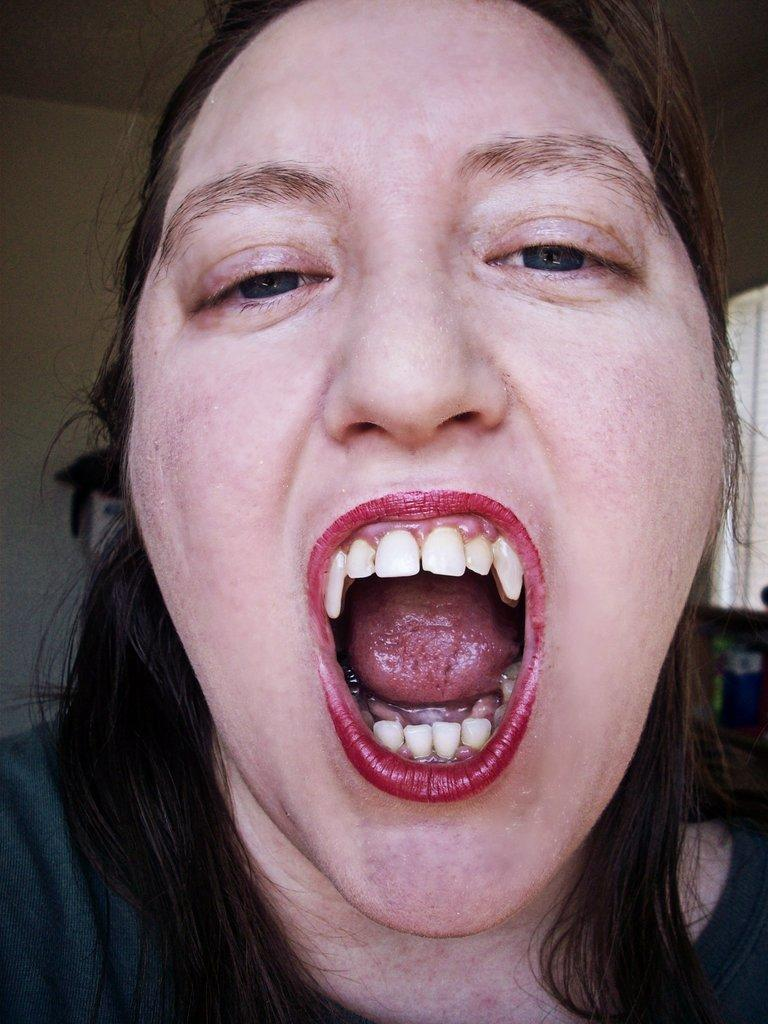Who is the main subject in the image? There is a woman in the image. What is the woman doing in the image? The woman is opening her mouth widely. Can you describe the background of the image? The background of the woman is blurred. What type of weather can be seen in the image? There is no weather visible in the image, as it is focused on the woman and her action. 